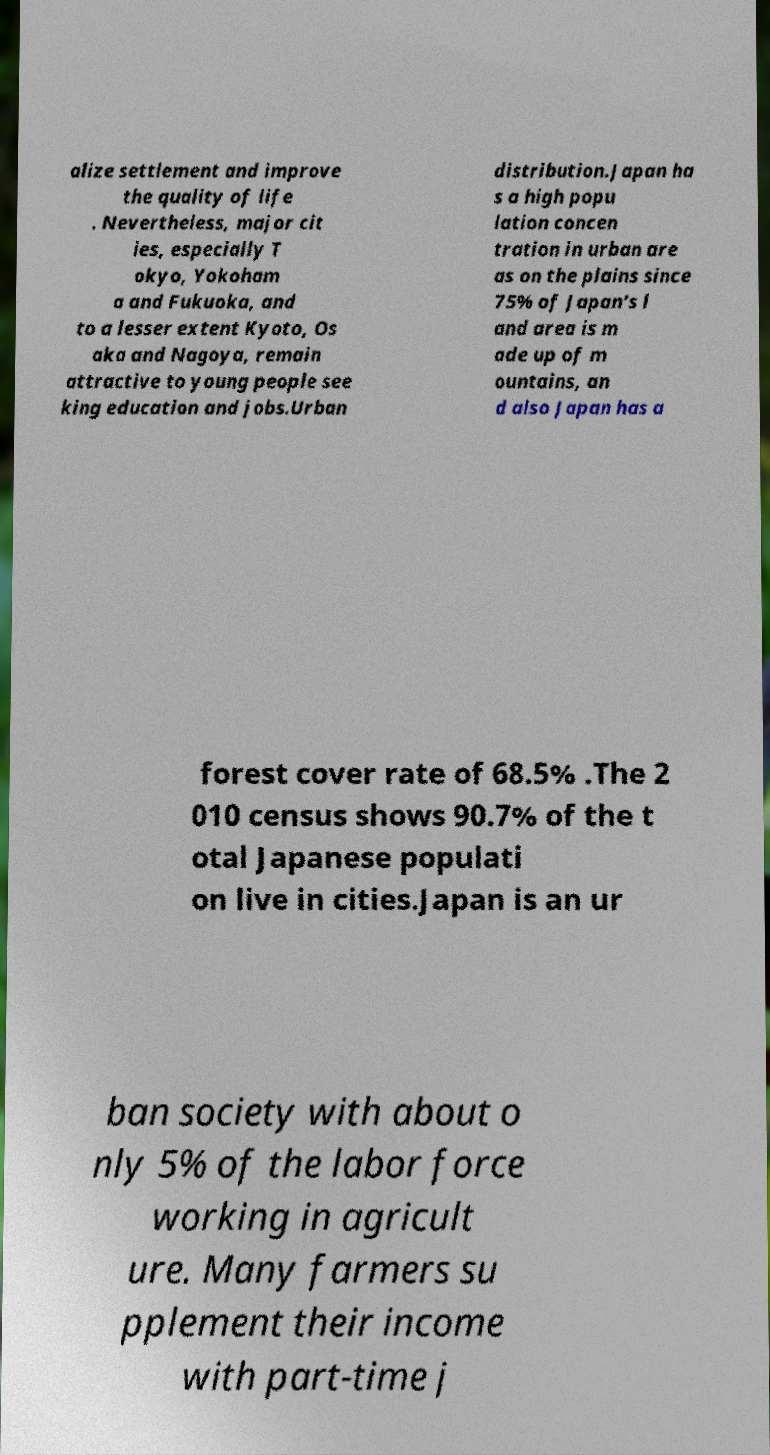For documentation purposes, I need the text within this image transcribed. Could you provide that? alize settlement and improve the quality of life . Nevertheless, major cit ies, especially T okyo, Yokoham a and Fukuoka, and to a lesser extent Kyoto, Os aka and Nagoya, remain attractive to young people see king education and jobs.Urban distribution.Japan ha s a high popu lation concen tration in urban are as on the plains since 75% of Japan’s l and area is m ade up of m ountains, an d also Japan has a forest cover rate of 68.5% .The 2 010 census shows 90.7% of the t otal Japanese populati on live in cities.Japan is an ur ban society with about o nly 5% of the labor force working in agricult ure. Many farmers su pplement their income with part-time j 